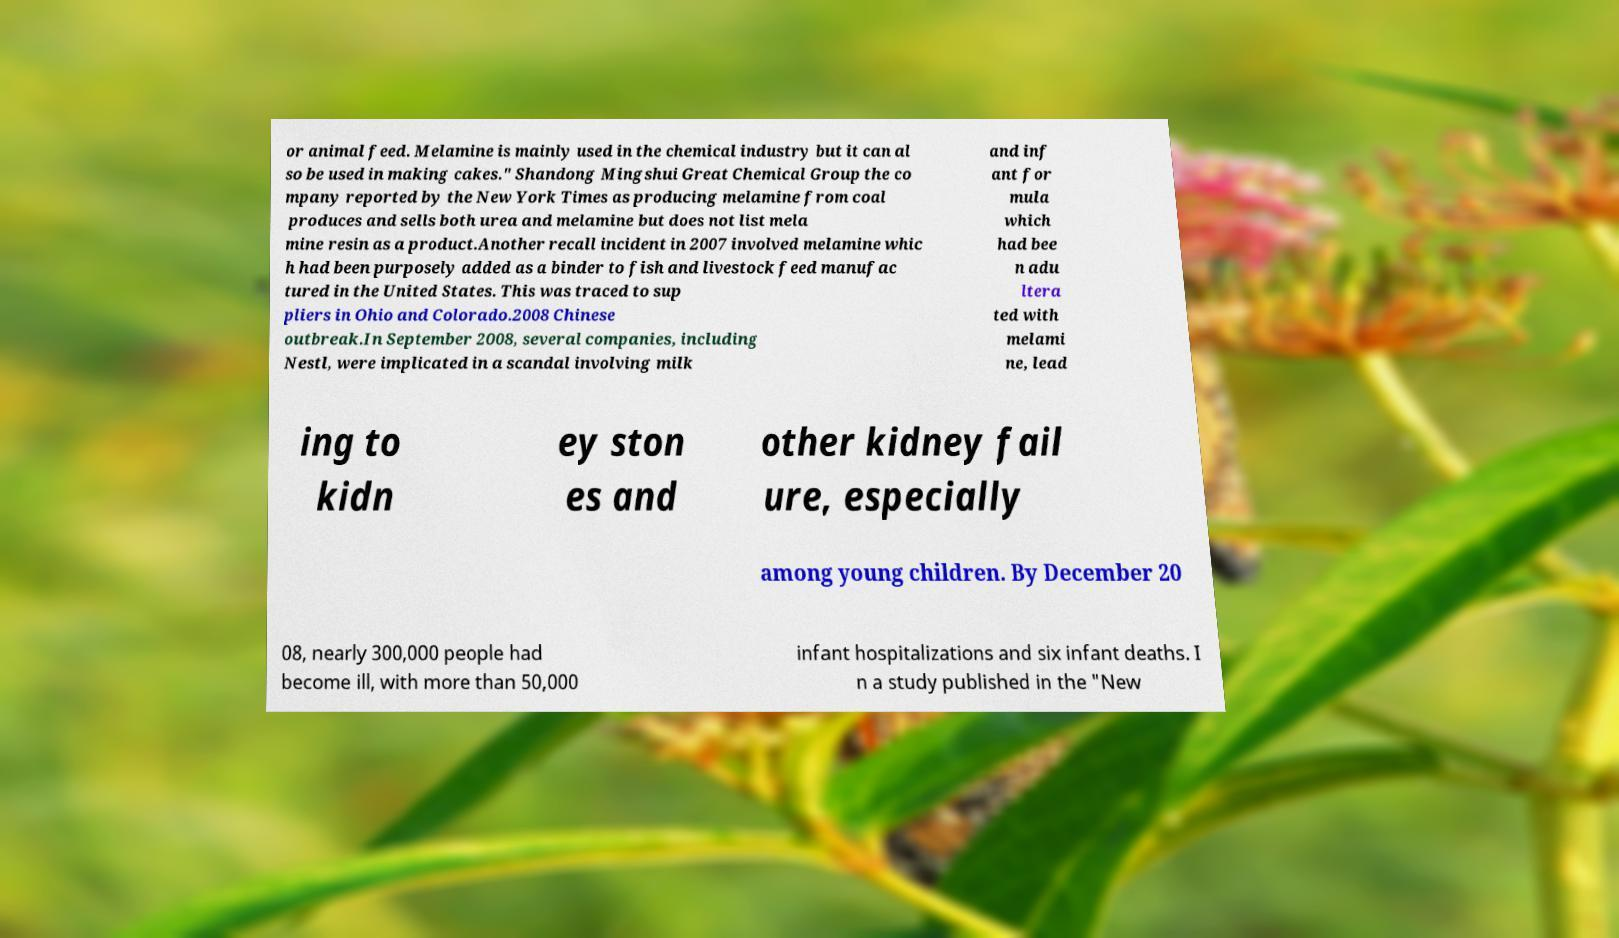There's text embedded in this image that I need extracted. Can you transcribe it verbatim? or animal feed. Melamine is mainly used in the chemical industry but it can al so be used in making cakes." Shandong Mingshui Great Chemical Group the co mpany reported by the New York Times as producing melamine from coal produces and sells both urea and melamine but does not list mela mine resin as a product.Another recall incident in 2007 involved melamine whic h had been purposely added as a binder to fish and livestock feed manufac tured in the United States. This was traced to sup pliers in Ohio and Colorado.2008 Chinese outbreak.In September 2008, several companies, including Nestl, were implicated in a scandal involving milk and inf ant for mula which had bee n adu ltera ted with melami ne, lead ing to kidn ey ston es and other kidney fail ure, especially among young children. By December 20 08, nearly 300,000 people had become ill, with more than 50,000 infant hospitalizations and six infant deaths. I n a study published in the "New 